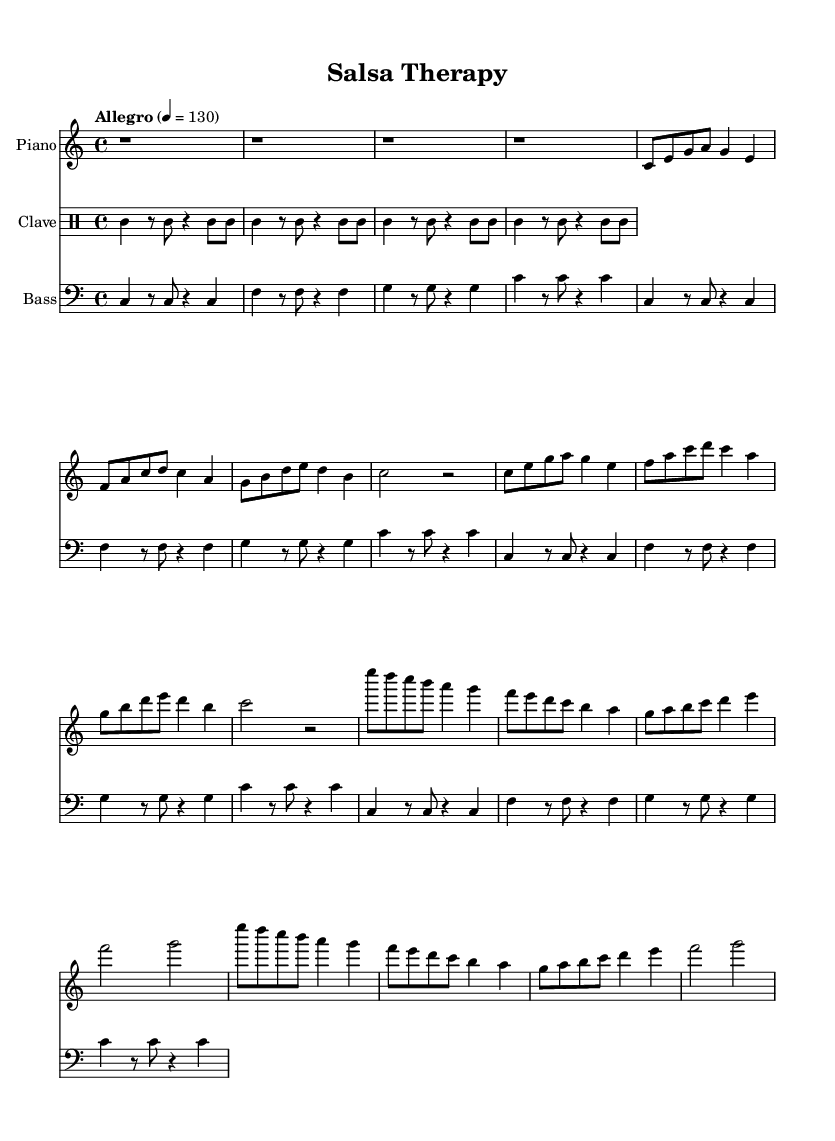What is the key signature of this music? The key signature is C major, which is indicated by the absence of sharps or flats.
Answer: C major What is the time signature? The time signature is indicated at the beginning of the score, showing 4 beats per measure, which is typical in salsa music.
Answer: 4/4 What is the tempo marking? The tempo marking indicates the speed of the music at an Allegro pace, specifically set to 130 beats per minute.
Answer: Allegro, 130 How many bars are in the introduction? The introduction consists of 4 measures, as shown by the notation before moving into the main themes.
Answer: 4 What are the main themes in this piece? There are two main themes identified in the score as Theme A and Theme B, each consisting of 8 measures.
Answer: Theme A and Theme B What instruments are used in this score? The score contains three instruments: Piano, Clave, and Bass. Each one is notated and labeled accordingly.
Answer: Piano, Clave, Bass Which rhythmic element is present in the clave part? The clave part shows the repeated rhythm pattern typical in Afro-Cuban music, specifically using the Clave rhythm which comprises contrasting hits.
Answer: Clave rhythm 